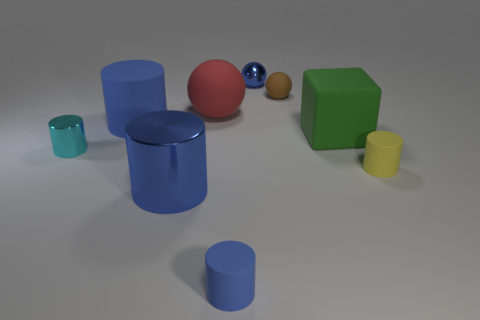How many objects are either shiny things in front of the yellow thing or large metallic things?
Your response must be concise. 1. Is the matte block the same color as the large shiny cylinder?
Make the answer very short. No. There is a matte object to the right of the big green thing; how big is it?
Provide a succinct answer. Small. Is there a cyan shiny sphere of the same size as the cyan shiny thing?
Offer a very short reply. No. There is a brown object to the right of the cyan object; is its size the same as the cyan thing?
Give a very brief answer. Yes. How big is the red sphere?
Ensure brevity in your answer.  Large. The large cylinder in front of the large thing that is right of the rubber sphere that is on the right side of the small blue metal sphere is what color?
Provide a short and direct response. Blue. Is the color of the tiny rubber cylinder that is right of the green object the same as the big shiny cylinder?
Provide a succinct answer. No. How many cylinders are both left of the tiny blue sphere and on the right side of the large green thing?
Your answer should be compact. 0. What size is the blue metal thing that is the same shape as the small cyan object?
Your answer should be compact. Large. 